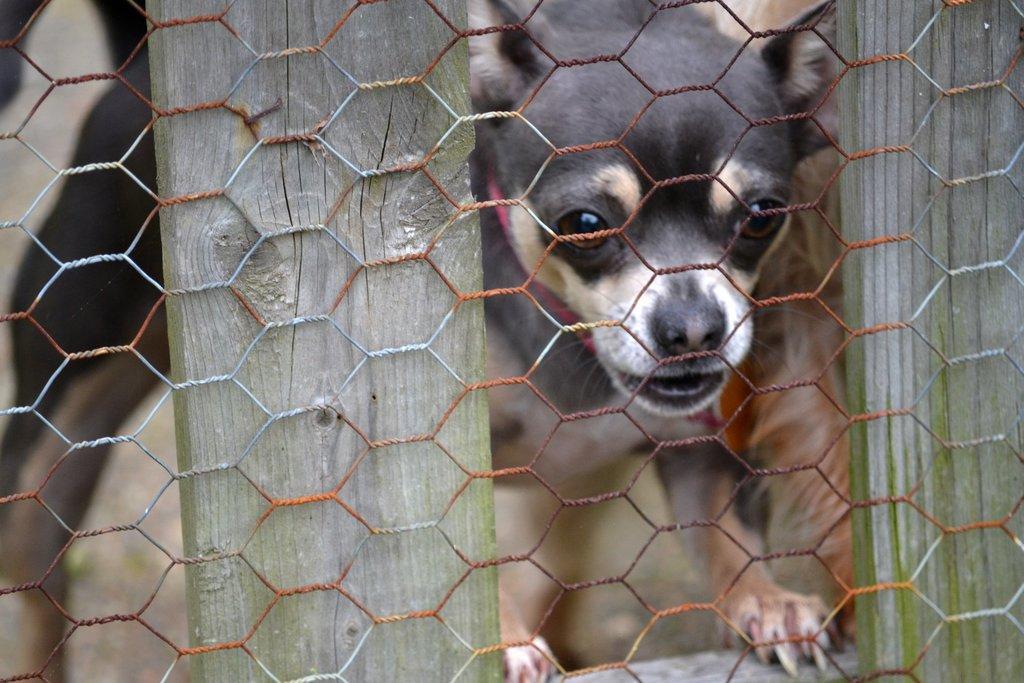Could you give a brief overview of what you see in this image? In this image there is a net fencing, behind the fencing there is a dog. 